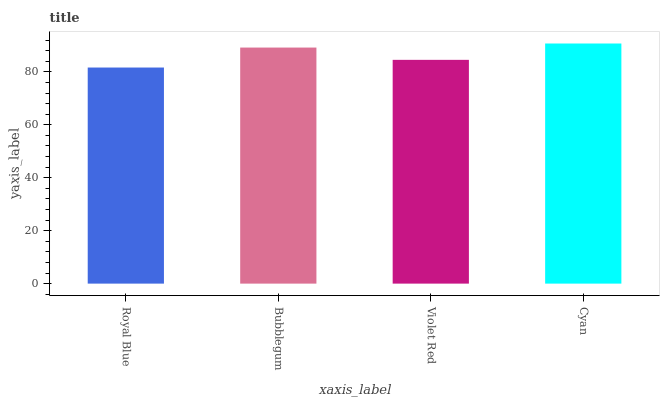Is Royal Blue the minimum?
Answer yes or no. Yes. Is Cyan the maximum?
Answer yes or no. Yes. Is Bubblegum the minimum?
Answer yes or no. No. Is Bubblegum the maximum?
Answer yes or no. No. Is Bubblegum greater than Royal Blue?
Answer yes or no. Yes. Is Royal Blue less than Bubblegum?
Answer yes or no. Yes. Is Royal Blue greater than Bubblegum?
Answer yes or no. No. Is Bubblegum less than Royal Blue?
Answer yes or no. No. Is Bubblegum the high median?
Answer yes or no. Yes. Is Violet Red the low median?
Answer yes or no. Yes. Is Violet Red the high median?
Answer yes or no. No. Is Royal Blue the low median?
Answer yes or no. No. 